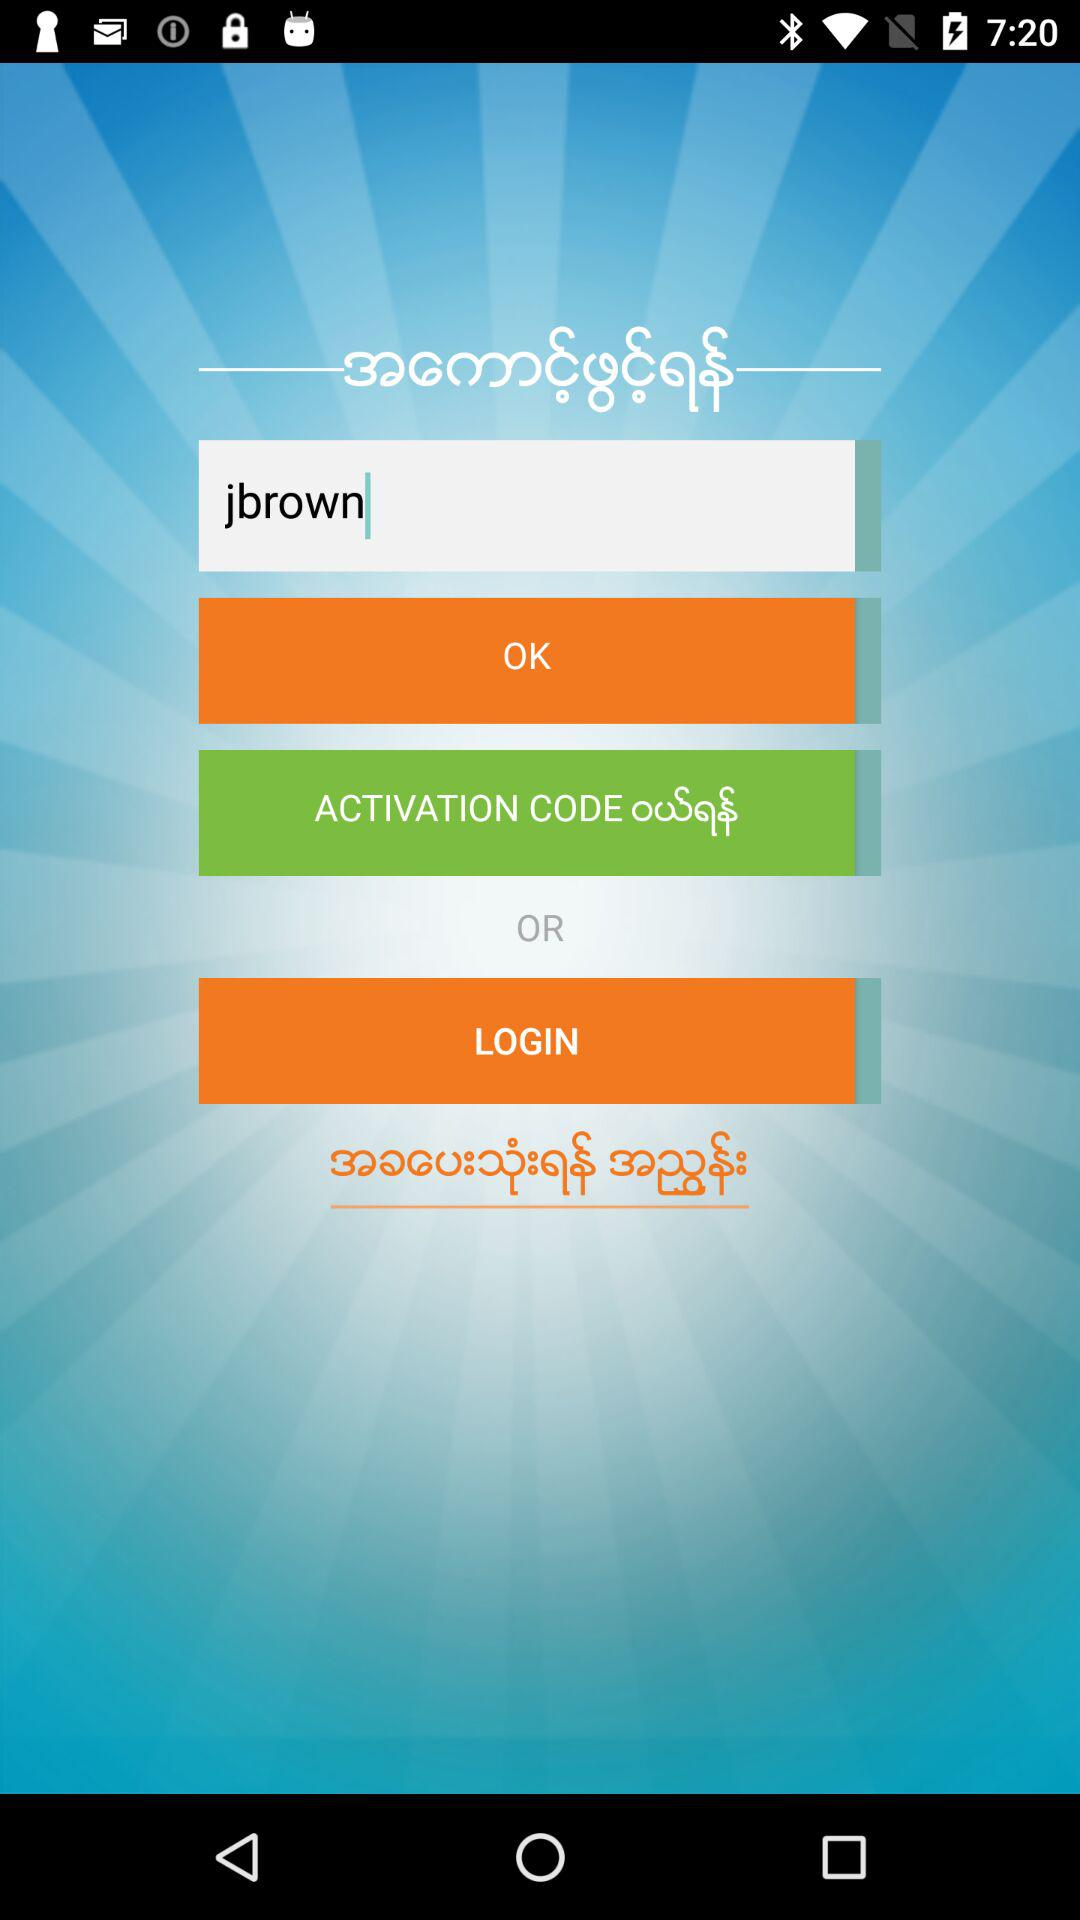How many text input fields are there on this screen?
Answer the question using a single word or phrase. 1 